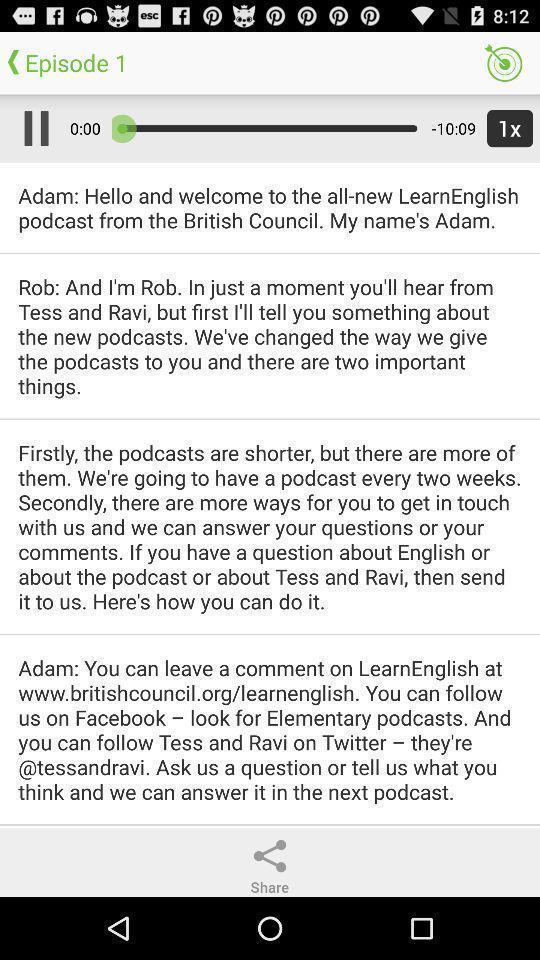Provide a description of this screenshot. Screen displaying conversation information between users. 